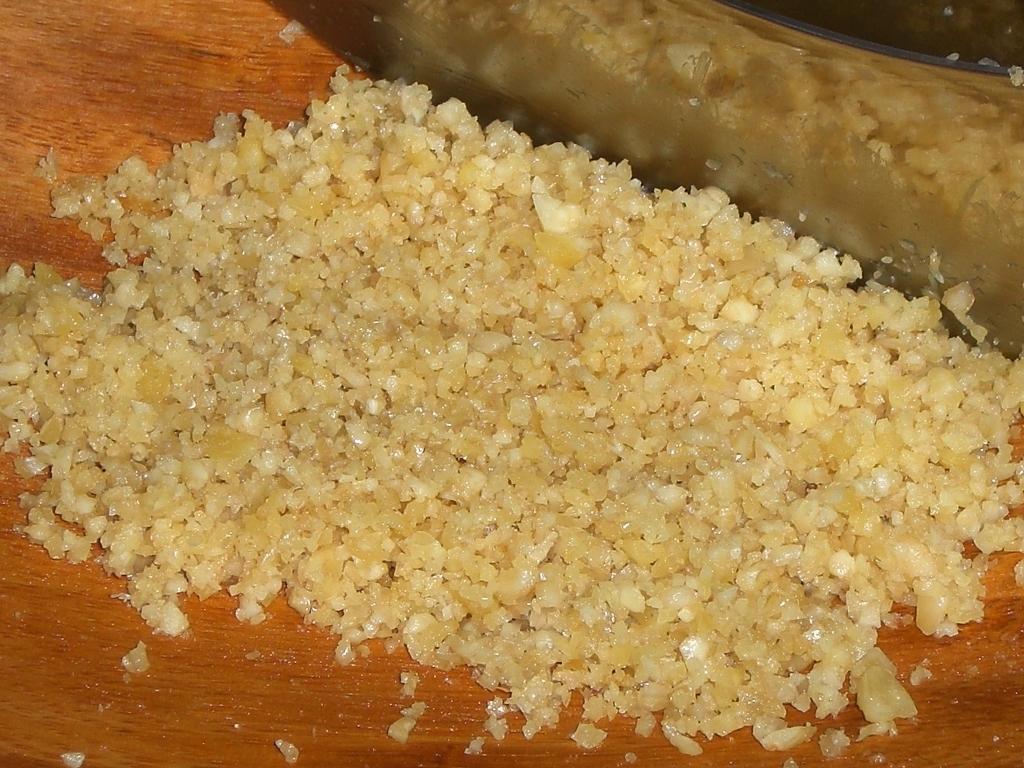Please provide a concise description of this image. In this image there is some food on the wooden plank, beside there is a knife. 